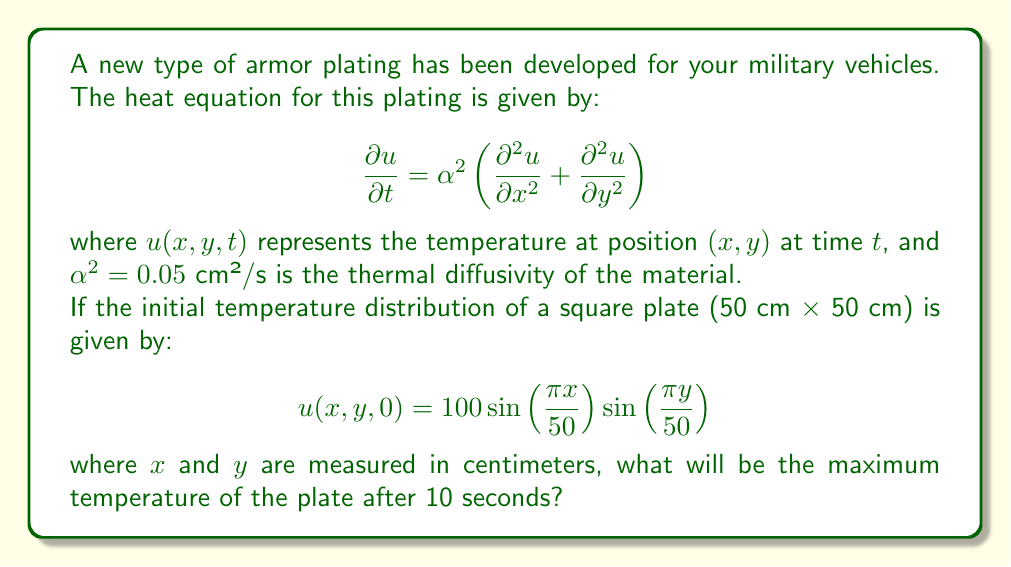Help me with this question. To solve this problem, we need to use the method of separation of variables for the 2D heat equation. The solution will be of the form:

$$u(x,y,t) = X(x)Y(y)T(t)$$

Given the initial condition, we can deduce that the spatial part of the solution will be:

$$X(x)Y(y) = \sin\left(\frac{\pi x}{50}\right) \sin\left(\frac{\pi y}{50}\right)$$

The temporal part $T(t)$ will be of the form:

$$T(t) = e^{-\lambda t}$$

where $\lambda$ is the eigenvalue. For the given spatial functions, we can determine $\lambda$:

$$\lambda = \alpha^2 \left(\left(\frac{\pi}{50}\right)^2 + \left(\frac{\pi}{50}\right)^2\right) = 0.05 \cdot 2\left(\frac{\pi}{50}\right)^2 = \frac{\pi^2}{25000}$$

Therefore, the complete solution is:

$$u(x,y,t) = 100 \sin\left(\frac{\pi x}{50}\right) \sin\left(\frac{\pi y}{50}\right) e^{-\frac{\pi^2}{25000}t}$$

To find the maximum temperature after 10 seconds, we need to evaluate:

$$u_{max}(10) = 100 \cdot e^{-\frac{\pi^2}{25000} \cdot 10}$$

$$u_{max}(10) = 100 \cdot e^{-0.0039478418 \cdot 10}$$

$$u_{max}(10) = 100 \cdot e^{-0.039478418}$$

$$u_{max}(10) = 100 \cdot 0.9612616959$$

$$u_{max}(10) = 96.12616959$$
Answer: The maximum temperature of the plate after 10 seconds will be approximately 96.13°C. 